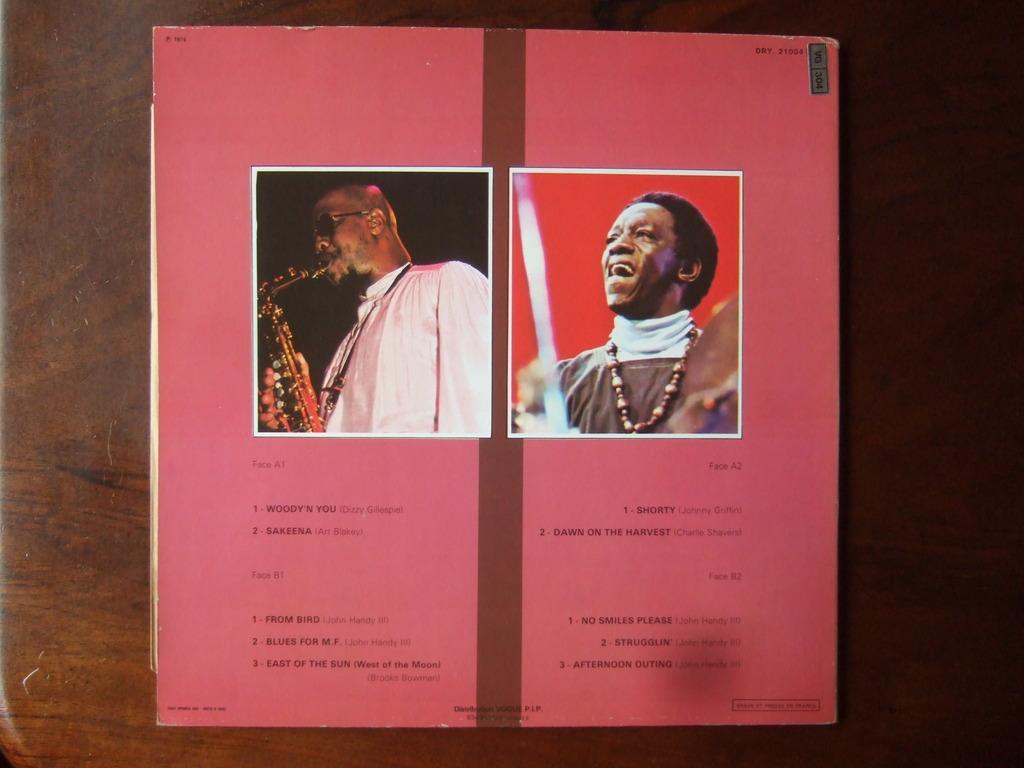How would you summarize this image in a sentence or two? In this picture there is a book which is kept on the table. On the book there are two photos of persons. Right person is wearing locket and dress and on the left person is wearing spectacle and white dress. And he is playing flute. 